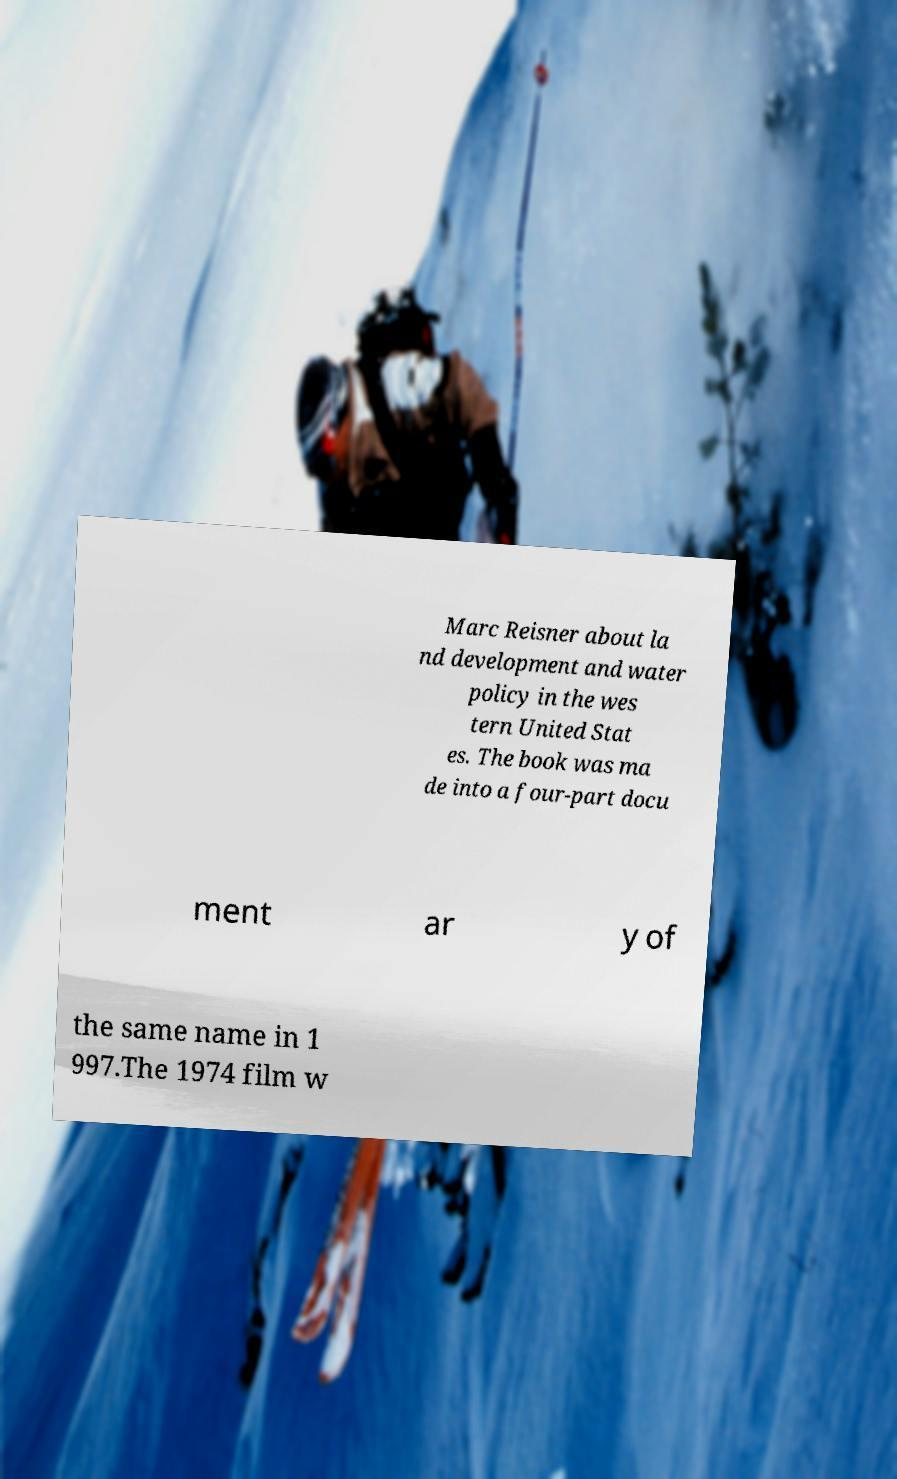What messages or text are displayed in this image? I need them in a readable, typed format. Marc Reisner about la nd development and water policy in the wes tern United Stat es. The book was ma de into a four-part docu ment ar y of the same name in 1 997.The 1974 film w 